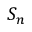Convert formula to latex. <formula><loc_0><loc_0><loc_500><loc_500>S _ { n }</formula> 